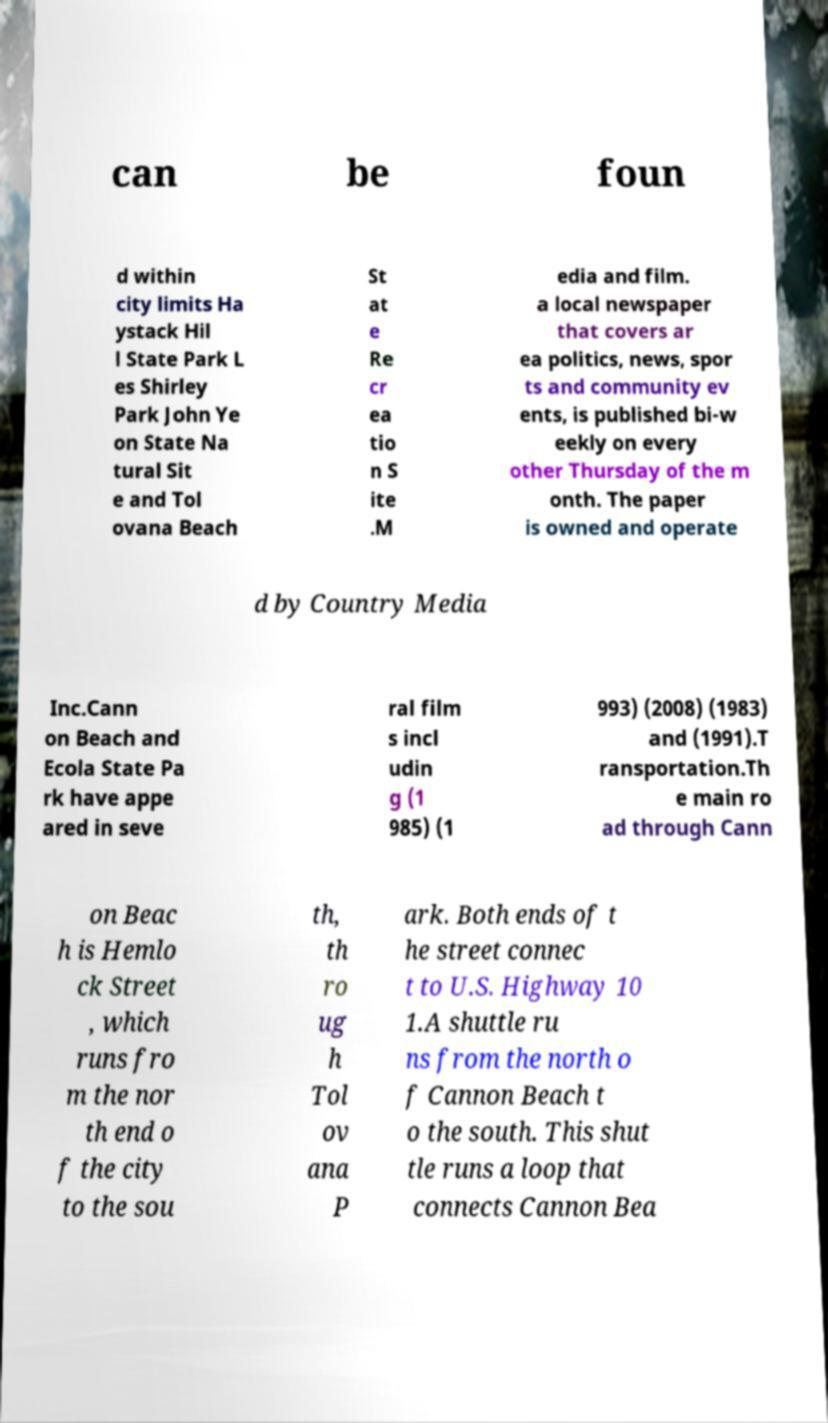Can you read and provide the text displayed in the image?This photo seems to have some interesting text. Can you extract and type it out for me? can be foun d within city limits Ha ystack Hil l State Park L es Shirley Park John Ye on State Na tural Sit e and Tol ovana Beach St at e Re cr ea tio n S ite .M edia and film. a local newspaper that covers ar ea politics, news, spor ts and community ev ents, is published bi-w eekly on every other Thursday of the m onth. The paper is owned and operate d by Country Media Inc.Cann on Beach and Ecola State Pa rk have appe ared in seve ral film s incl udin g (1 985) (1 993) (2008) (1983) and (1991).T ransportation.Th e main ro ad through Cann on Beac h is Hemlo ck Street , which runs fro m the nor th end o f the city to the sou th, th ro ug h Tol ov ana P ark. Both ends of t he street connec t to U.S. Highway 10 1.A shuttle ru ns from the north o f Cannon Beach t o the south. This shut tle runs a loop that connects Cannon Bea 